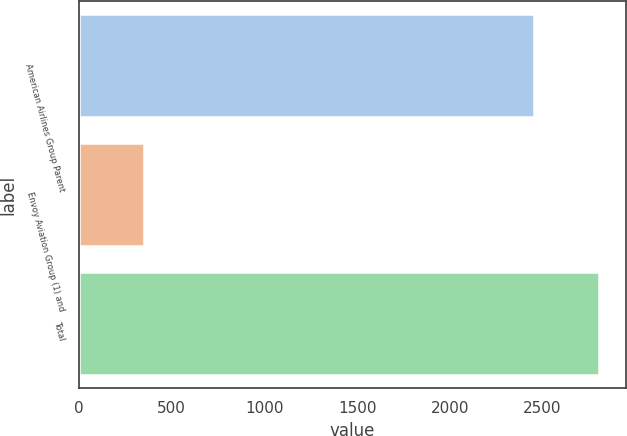Convert chart to OTSL. <chart><loc_0><loc_0><loc_500><loc_500><bar_chart><fcel>American Airlines Group Parent<fcel>Envoy Aviation Group (1) and<fcel>Total<nl><fcel>2455<fcel>352<fcel>2807<nl></chart> 